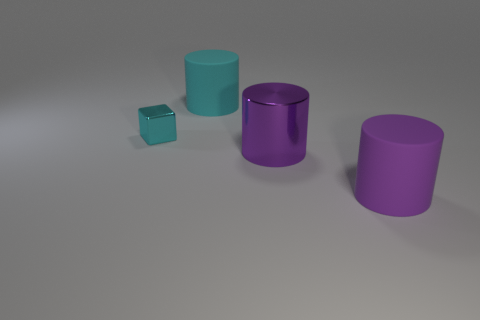Add 1 tiny cyan things. How many objects exist? 5 Subtract all cubes. How many objects are left? 3 Subtract all purple matte spheres. Subtract all purple things. How many objects are left? 2 Add 2 small cyan objects. How many small cyan objects are left? 3 Add 3 tiny metal things. How many tiny metal things exist? 4 Subtract 1 cyan cubes. How many objects are left? 3 